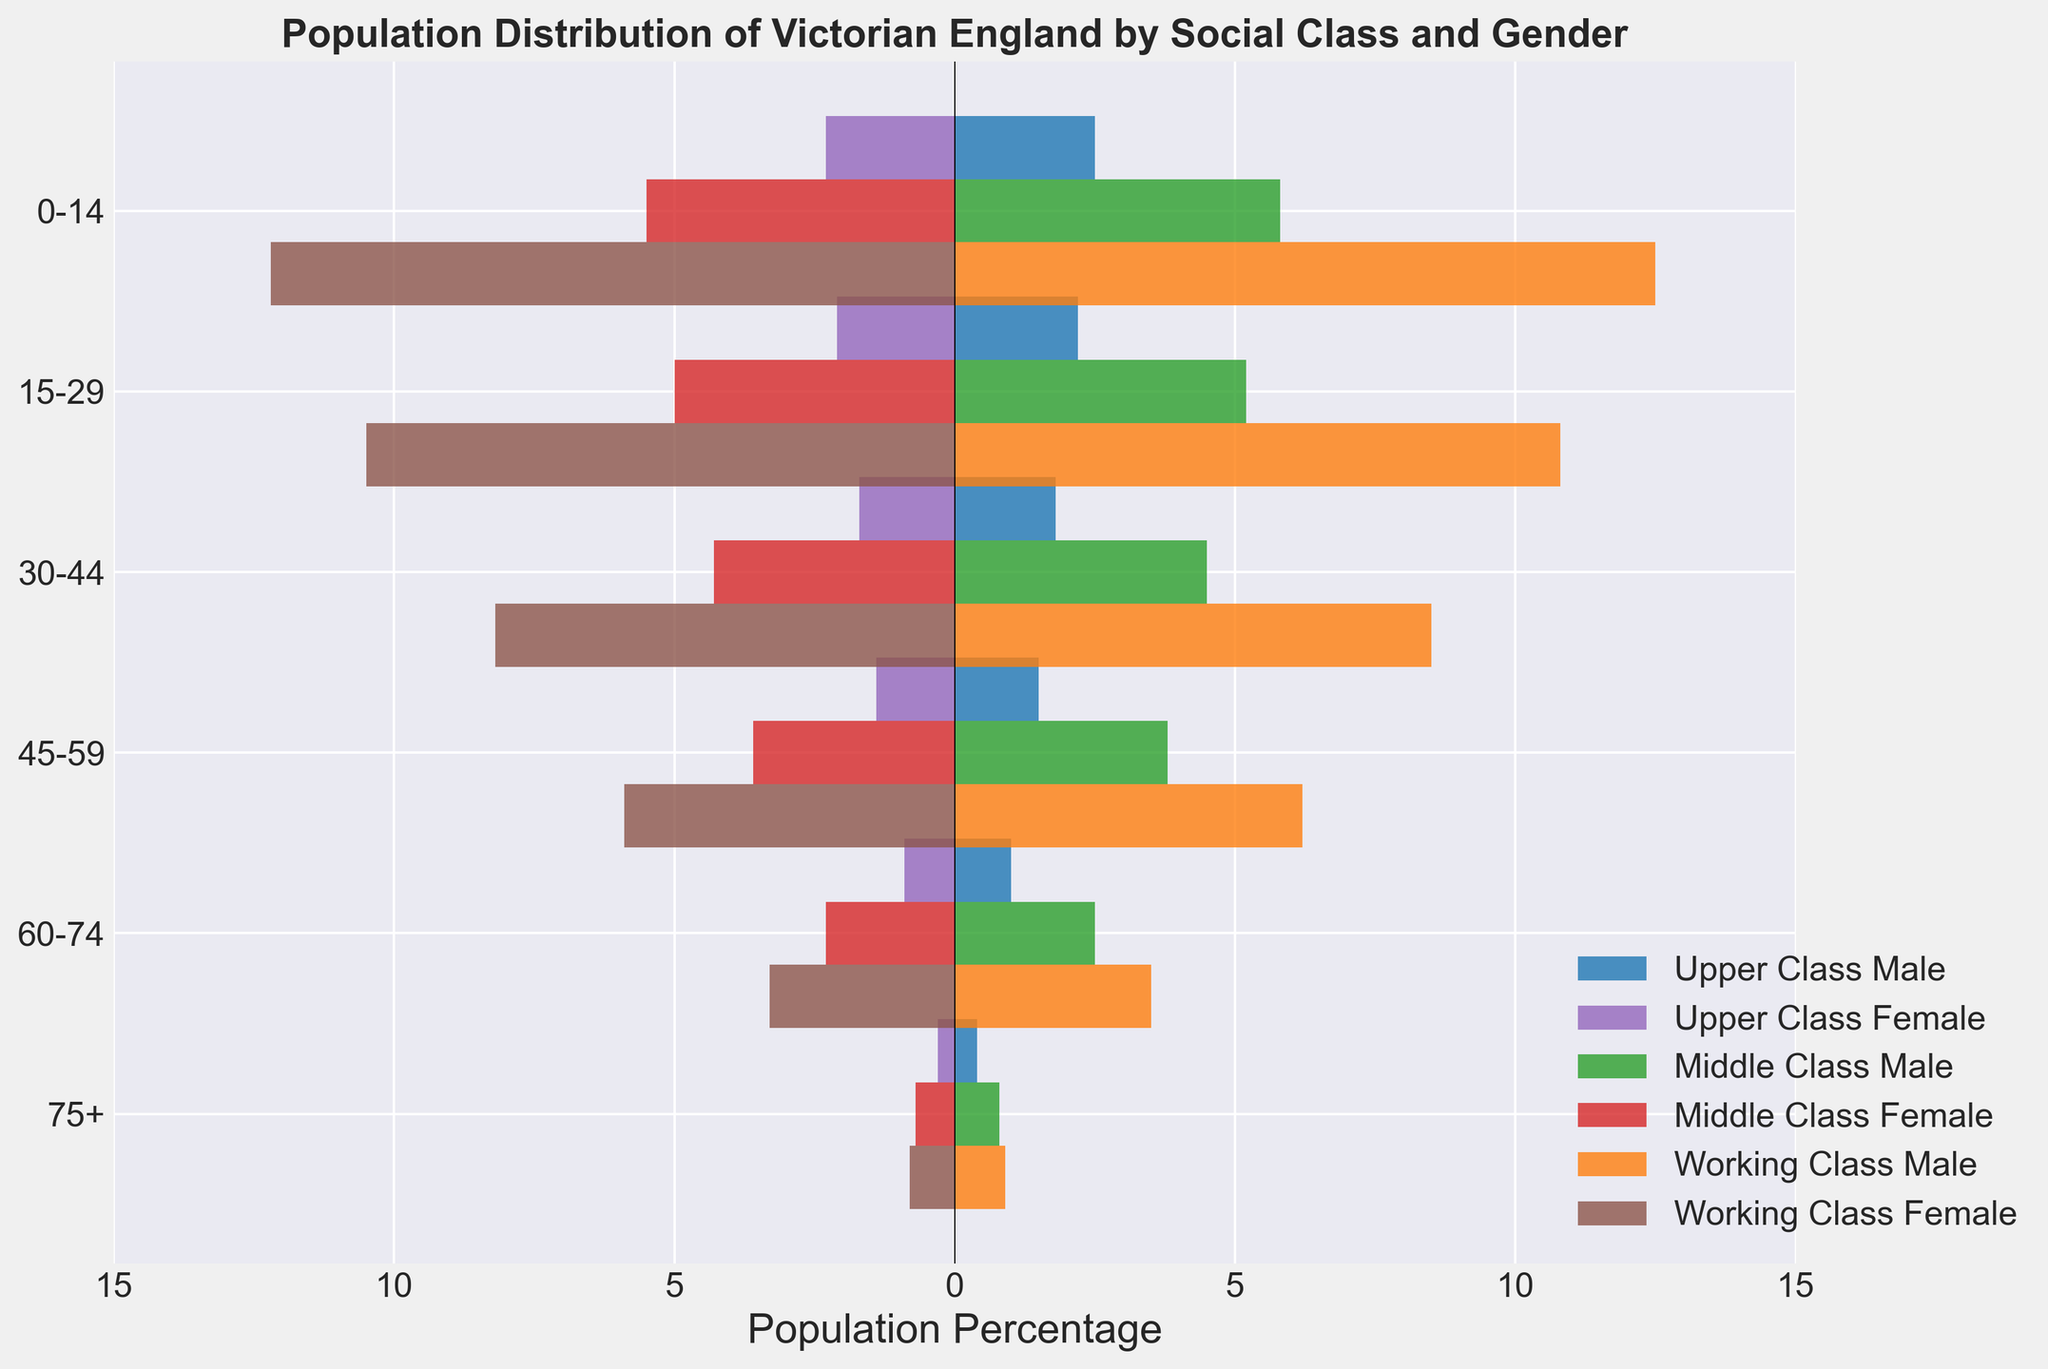What is the title of the chart? The title is usually located at the top of the chart. In this figure, it reads "Population Distribution of Victorian England by Social Class and Gender."
Answer: Population Distribution of Victorian England by Social Class and Gender What is the age group with the highest percentage in the working-class male category? To determine this, look at the lengths of the bars corresponding to the working-class male category for each age group. The longest bar indicates the highest percentage.
Answer: 0-14 Which social class and gender category had the smallest population percentage in the 75+ age group? Look at the bars for the 75+ age group, and compare their lengths. The shortest bar represents the smallest population percentage.
Answer: Upper Class Female How does the population percentage of middle-class females aged 45-59 compare to middle-class males in the same age group? Locate the bars for the middle-class males and females in the 45-59 age group and compare their lengths. The bar for males should be slightly longer than the bar for females.
Answer: Middle Class Male is higher Which age group shows the greatest disparity between upper-class males and females? Identify the age groups and compare the lengths of the corresponding bars for upper-class males and females. The greatest disparity is seen where the difference in bar lengths is most significant.
Answer: 0-14 Across all social classes, which gender has a higher population percentage for those aged 15-29? Sum the population percentages of males and females across all three social classes within the 15-29 age group, and compare the totals for each gender.
Answer: Male Which social class and gender had the highest population percentage among those aged 30-44? Examine the bars for the 30-44 age group and determine which social class and gender have the longest bar.
Answer: Working Class Male What is the difference in population percentage between the upper-class and working-class females aged 60-74? Identify the population percentages for the upper-class and working-class females in the 60-74 age group, and subtract the upper-class percentage from the working-class percentage.
Answer: 2.4 Among the upper-class males, which age group has the lowest population percentage? Look at the bars representing upper-class males across all age groups to find the shortest bar.
Answer: 75+ What can we infer about the working-class female population in comparison to the middle-class females in the 0-14 age group? Compare the lengths of the bars for working-class and middle-class females in the 0-14 age group. The length of the bar indicates that the population percentage is higher for working-class females.
Answer: Working Class Female is higher 